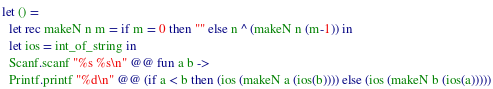<code> <loc_0><loc_0><loc_500><loc_500><_OCaml_>let () =
  let rec makeN n m = if m = 0 then "" else n ^ (makeN n (m-1)) in
  let ios = int_of_string in
  Scanf.scanf "%s %s\n" @@ fun a b ->
  Printf.printf "%d\n" @@ (if a < b then (ios (makeN a (ios(b)))) else (ios (makeN b (ios(a)))))</code> 